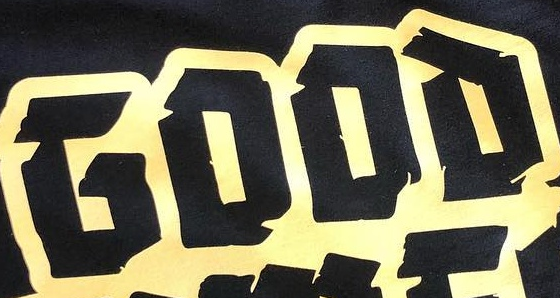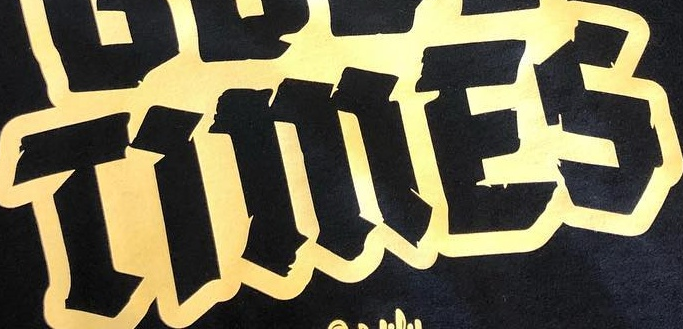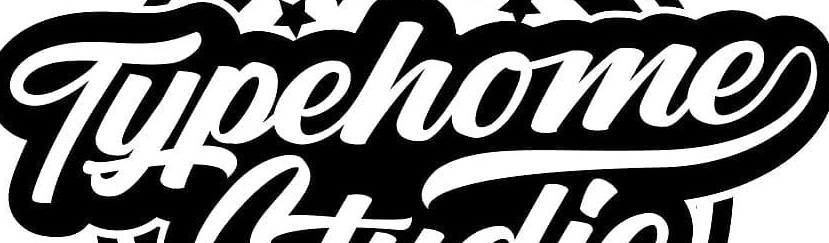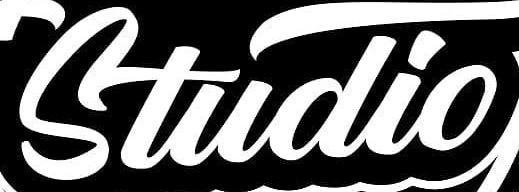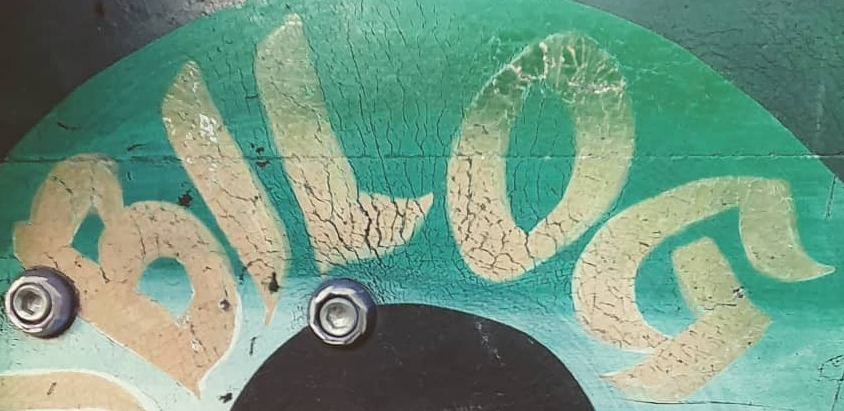What text appears in these images from left to right, separated by a semicolon? GOOD; TiMES; Typehome; Studio; BILOG 